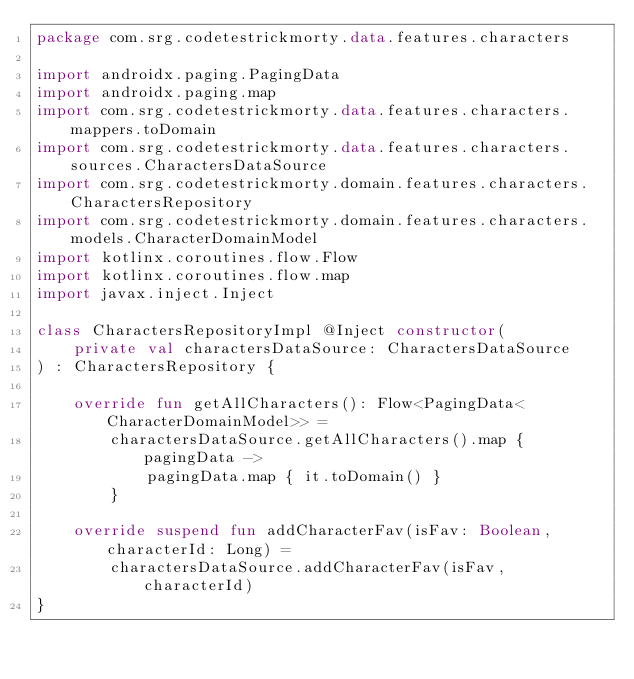<code> <loc_0><loc_0><loc_500><loc_500><_Kotlin_>package com.srg.codetestrickmorty.data.features.characters

import androidx.paging.PagingData
import androidx.paging.map
import com.srg.codetestrickmorty.data.features.characters.mappers.toDomain
import com.srg.codetestrickmorty.data.features.characters.sources.CharactersDataSource
import com.srg.codetestrickmorty.domain.features.characters.CharactersRepository
import com.srg.codetestrickmorty.domain.features.characters.models.CharacterDomainModel
import kotlinx.coroutines.flow.Flow
import kotlinx.coroutines.flow.map
import javax.inject.Inject

class CharactersRepositoryImpl @Inject constructor(
    private val charactersDataSource: CharactersDataSource
) : CharactersRepository {

    override fun getAllCharacters(): Flow<PagingData<CharacterDomainModel>> =
        charactersDataSource.getAllCharacters().map { pagingData ->
            pagingData.map { it.toDomain() }
        }

    override suspend fun addCharacterFav(isFav: Boolean, characterId: Long) =
        charactersDataSource.addCharacterFav(isFav, characterId)
}</code> 